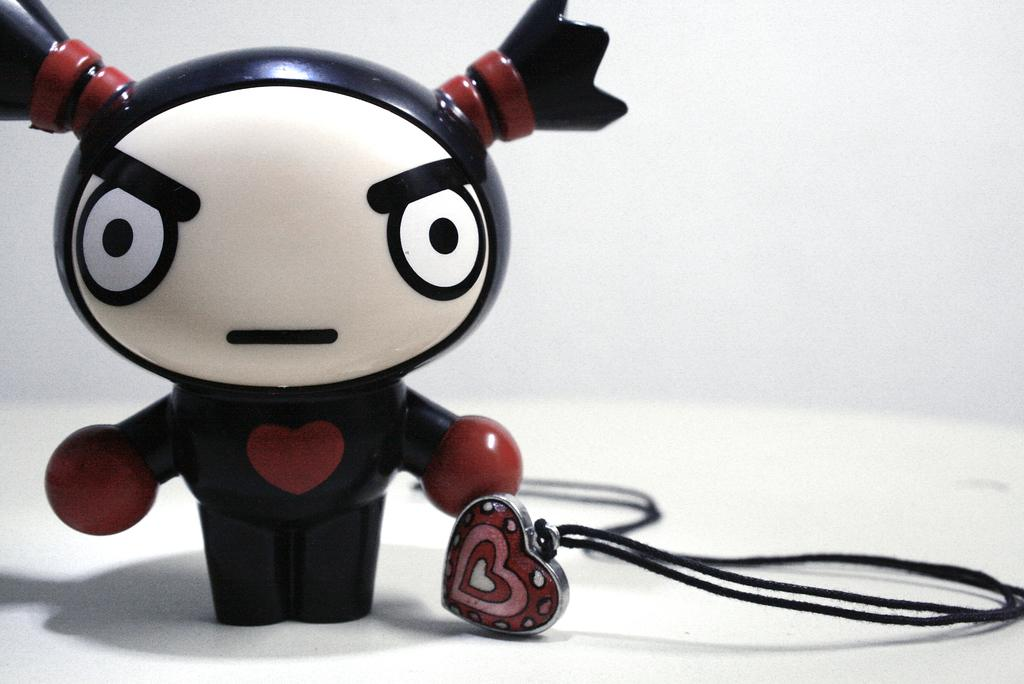What type of object can be seen in the image? There is a toy in the image. What other object is present in the image? There is a locket in the image. What color is the background of the image? The background of the image is white. Can you see any deer in the image? No, there are no deer present in the image. What type of amphibian can be seen in the image? There are no amphibians, such as toads, present in the image. 